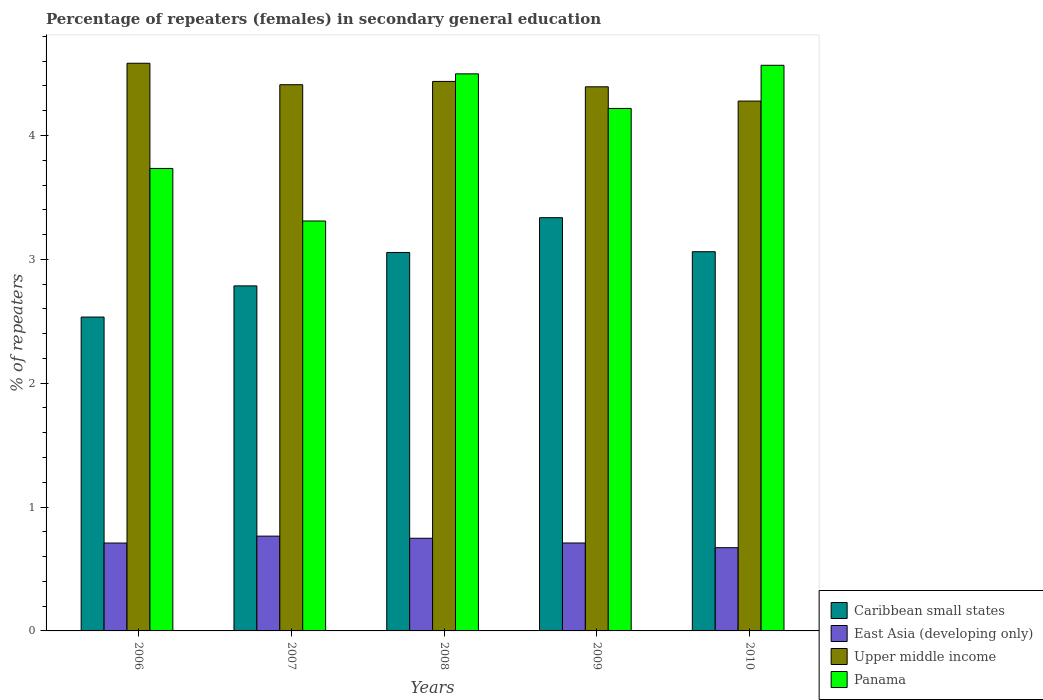How many groups of bars are there?
Your answer should be compact. 5. Are the number of bars per tick equal to the number of legend labels?
Give a very brief answer. Yes. How many bars are there on the 4th tick from the left?
Provide a short and direct response. 4. How many bars are there on the 3rd tick from the right?
Give a very brief answer. 4. What is the label of the 1st group of bars from the left?
Offer a terse response. 2006. In how many cases, is the number of bars for a given year not equal to the number of legend labels?
Offer a very short reply. 0. What is the percentage of female repeaters in Caribbean small states in 2010?
Your answer should be very brief. 3.06. Across all years, what is the maximum percentage of female repeaters in Upper middle income?
Your response must be concise. 4.58. Across all years, what is the minimum percentage of female repeaters in Caribbean small states?
Offer a terse response. 2.53. In which year was the percentage of female repeaters in Caribbean small states maximum?
Ensure brevity in your answer.  2009. In which year was the percentage of female repeaters in Upper middle income minimum?
Offer a terse response. 2010. What is the total percentage of female repeaters in East Asia (developing only) in the graph?
Provide a short and direct response. 3.61. What is the difference between the percentage of female repeaters in East Asia (developing only) in 2006 and that in 2009?
Provide a short and direct response. -0. What is the difference between the percentage of female repeaters in Caribbean small states in 2008 and the percentage of female repeaters in Upper middle income in 2010?
Make the answer very short. -1.22. What is the average percentage of female repeaters in East Asia (developing only) per year?
Provide a succinct answer. 0.72. In the year 2008, what is the difference between the percentage of female repeaters in Panama and percentage of female repeaters in Caribbean small states?
Ensure brevity in your answer.  1.44. In how many years, is the percentage of female repeaters in East Asia (developing only) greater than 4.6 %?
Your answer should be very brief. 0. What is the ratio of the percentage of female repeaters in Panama in 2007 to that in 2008?
Provide a succinct answer. 0.74. What is the difference between the highest and the second highest percentage of female repeaters in Panama?
Give a very brief answer. 0.07. What is the difference between the highest and the lowest percentage of female repeaters in Panama?
Offer a very short reply. 1.26. Is the sum of the percentage of female repeaters in East Asia (developing only) in 2006 and 2009 greater than the maximum percentage of female repeaters in Upper middle income across all years?
Give a very brief answer. No. What does the 1st bar from the left in 2007 represents?
Your answer should be very brief. Caribbean small states. What does the 3rd bar from the right in 2006 represents?
Make the answer very short. East Asia (developing only). How many years are there in the graph?
Your answer should be very brief. 5. Are the values on the major ticks of Y-axis written in scientific E-notation?
Your answer should be compact. No. Does the graph contain any zero values?
Offer a terse response. No. How many legend labels are there?
Ensure brevity in your answer.  4. How are the legend labels stacked?
Keep it short and to the point. Vertical. What is the title of the graph?
Provide a succinct answer. Percentage of repeaters (females) in secondary general education. What is the label or title of the X-axis?
Your response must be concise. Years. What is the label or title of the Y-axis?
Offer a very short reply. % of repeaters. What is the % of repeaters in Caribbean small states in 2006?
Give a very brief answer. 2.53. What is the % of repeaters of East Asia (developing only) in 2006?
Keep it short and to the point. 0.71. What is the % of repeaters of Upper middle income in 2006?
Give a very brief answer. 4.58. What is the % of repeaters of Panama in 2006?
Offer a terse response. 3.73. What is the % of repeaters of Caribbean small states in 2007?
Offer a terse response. 2.79. What is the % of repeaters of East Asia (developing only) in 2007?
Provide a succinct answer. 0.77. What is the % of repeaters in Upper middle income in 2007?
Keep it short and to the point. 4.41. What is the % of repeaters in Panama in 2007?
Your response must be concise. 3.31. What is the % of repeaters of Caribbean small states in 2008?
Offer a terse response. 3.06. What is the % of repeaters in East Asia (developing only) in 2008?
Your answer should be compact. 0.75. What is the % of repeaters of Upper middle income in 2008?
Your answer should be very brief. 4.44. What is the % of repeaters of Panama in 2008?
Provide a short and direct response. 4.5. What is the % of repeaters of Caribbean small states in 2009?
Give a very brief answer. 3.34. What is the % of repeaters of East Asia (developing only) in 2009?
Keep it short and to the point. 0.71. What is the % of repeaters of Upper middle income in 2009?
Make the answer very short. 4.39. What is the % of repeaters of Panama in 2009?
Offer a very short reply. 4.22. What is the % of repeaters of Caribbean small states in 2010?
Ensure brevity in your answer.  3.06. What is the % of repeaters of East Asia (developing only) in 2010?
Your answer should be very brief. 0.67. What is the % of repeaters in Upper middle income in 2010?
Make the answer very short. 4.28. What is the % of repeaters in Panama in 2010?
Offer a terse response. 4.57. Across all years, what is the maximum % of repeaters in Caribbean small states?
Ensure brevity in your answer.  3.34. Across all years, what is the maximum % of repeaters in East Asia (developing only)?
Offer a terse response. 0.77. Across all years, what is the maximum % of repeaters of Upper middle income?
Provide a succinct answer. 4.58. Across all years, what is the maximum % of repeaters in Panama?
Offer a terse response. 4.57. Across all years, what is the minimum % of repeaters in Caribbean small states?
Provide a succinct answer. 2.53. Across all years, what is the minimum % of repeaters of East Asia (developing only)?
Your response must be concise. 0.67. Across all years, what is the minimum % of repeaters in Upper middle income?
Provide a short and direct response. 4.28. Across all years, what is the minimum % of repeaters in Panama?
Your answer should be very brief. 3.31. What is the total % of repeaters of Caribbean small states in the graph?
Offer a very short reply. 14.77. What is the total % of repeaters of East Asia (developing only) in the graph?
Give a very brief answer. 3.6. What is the total % of repeaters of Upper middle income in the graph?
Your answer should be very brief. 22.1. What is the total % of repeaters in Panama in the graph?
Provide a succinct answer. 20.33. What is the difference between the % of repeaters in Caribbean small states in 2006 and that in 2007?
Ensure brevity in your answer.  -0.25. What is the difference between the % of repeaters in East Asia (developing only) in 2006 and that in 2007?
Offer a very short reply. -0.06. What is the difference between the % of repeaters in Upper middle income in 2006 and that in 2007?
Your answer should be compact. 0.17. What is the difference between the % of repeaters of Panama in 2006 and that in 2007?
Give a very brief answer. 0.42. What is the difference between the % of repeaters of Caribbean small states in 2006 and that in 2008?
Your answer should be very brief. -0.52. What is the difference between the % of repeaters of East Asia (developing only) in 2006 and that in 2008?
Keep it short and to the point. -0.04. What is the difference between the % of repeaters in Upper middle income in 2006 and that in 2008?
Ensure brevity in your answer.  0.15. What is the difference between the % of repeaters in Panama in 2006 and that in 2008?
Your response must be concise. -0.76. What is the difference between the % of repeaters of Caribbean small states in 2006 and that in 2009?
Make the answer very short. -0.8. What is the difference between the % of repeaters in East Asia (developing only) in 2006 and that in 2009?
Offer a terse response. -0. What is the difference between the % of repeaters in Upper middle income in 2006 and that in 2009?
Make the answer very short. 0.19. What is the difference between the % of repeaters of Panama in 2006 and that in 2009?
Ensure brevity in your answer.  -0.48. What is the difference between the % of repeaters of Caribbean small states in 2006 and that in 2010?
Your answer should be very brief. -0.53. What is the difference between the % of repeaters of East Asia (developing only) in 2006 and that in 2010?
Make the answer very short. 0.04. What is the difference between the % of repeaters in Upper middle income in 2006 and that in 2010?
Give a very brief answer. 0.31. What is the difference between the % of repeaters in Panama in 2006 and that in 2010?
Keep it short and to the point. -0.83. What is the difference between the % of repeaters in Caribbean small states in 2007 and that in 2008?
Ensure brevity in your answer.  -0.27. What is the difference between the % of repeaters in East Asia (developing only) in 2007 and that in 2008?
Your response must be concise. 0.02. What is the difference between the % of repeaters of Upper middle income in 2007 and that in 2008?
Provide a short and direct response. -0.03. What is the difference between the % of repeaters of Panama in 2007 and that in 2008?
Offer a terse response. -1.19. What is the difference between the % of repeaters in Caribbean small states in 2007 and that in 2009?
Your answer should be compact. -0.55. What is the difference between the % of repeaters of East Asia (developing only) in 2007 and that in 2009?
Your response must be concise. 0.06. What is the difference between the % of repeaters of Upper middle income in 2007 and that in 2009?
Your response must be concise. 0.02. What is the difference between the % of repeaters of Panama in 2007 and that in 2009?
Make the answer very short. -0.91. What is the difference between the % of repeaters of Caribbean small states in 2007 and that in 2010?
Give a very brief answer. -0.28. What is the difference between the % of repeaters of East Asia (developing only) in 2007 and that in 2010?
Offer a terse response. 0.09. What is the difference between the % of repeaters of Upper middle income in 2007 and that in 2010?
Make the answer very short. 0.13. What is the difference between the % of repeaters of Panama in 2007 and that in 2010?
Ensure brevity in your answer.  -1.26. What is the difference between the % of repeaters of Caribbean small states in 2008 and that in 2009?
Offer a terse response. -0.28. What is the difference between the % of repeaters of East Asia (developing only) in 2008 and that in 2009?
Provide a succinct answer. 0.04. What is the difference between the % of repeaters in Upper middle income in 2008 and that in 2009?
Keep it short and to the point. 0.04. What is the difference between the % of repeaters of Panama in 2008 and that in 2009?
Ensure brevity in your answer.  0.28. What is the difference between the % of repeaters of Caribbean small states in 2008 and that in 2010?
Ensure brevity in your answer.  -0.01. What is the difference between the % of repeaters of East Asia (developing only) in 2008 and that in 2010?
Your response must be concise. 0.08. What is the difference between the % of repeaters of Upper middle income in 2008 and that in 2010?
Provide a succinct answer. 0.16. What is the difference between the % of repeaters of Panama in 2008 and that in 2010?
Make the answer very short. -0.07. What is the difference between the % of repeaters in Caribbean small states in 2009 and that in 2010?
Keep it short and to the point. 0.27. What is the difference between the % of repeaters of East Asia (developing only) in 2009 and that in 2010?
Your response must be concise. 0.04. What is the difference between the % of repeaters in Upper middle income in 2009 and that in 2010?
Provide a succinct answer. 0.12. What is the difference between the % of repeaters of Panama in 2009 and that in 2010?
Your answer should be compact. -0.35. What is the difference between the % of repeaters in Caribbean small states in 2006 and the % of repeaters in East Asia (developing only) in 2007?
Make the answer very short. 1.77. What is the difference between the % of repeaters of Caribbean small states in 2006 and the % of repeaters of Upper middle income in 2007?
Make the answer very short. -1.88. What is the difference between the % of repeaters in Caribbean small states in 2006 and the % of repeaters in Panama in 2007?
Your response must be concise. -0.78. What is the difference between the % of repeaters of East Asia (developing only) in 2006 and the % of repeaters of Upper middle income in 2007?
Keep it short and to the point. -3.7. What is the difference between the % of repeaters of East Asia (developing only) in 2006 and the % of repeaters of Panama in 2007?
Give a very brief answer. -2.6. What is the difference between the % of repeaters in Upper middle income in 2006 and the % of repeaters in Panama in 2007?
Keep it short and to the point. 1.27. What is the difference between the % of repeaters of Caribbean small states in 2006 and the % of repeaters of East Asia (developing only) in 2008?
Your response must be concise. 1.79. What is the difference between the % of repeaters of Caribbean small states in 2006 and the % of repeaters of Upper middle income in 2008?
Keep it short and to the point. -1.9. What is the difference between the % of repeaters of Caribbean small states in 2006 and the % of repeaters of Panama in 2008?
Your answer should be compact. -1.96. What is the difference between the % of repeaters of East Asia (developing only) in 2006 and the % of repeaters of Upper middle income in 2008?
Provide a short and direct response. -3.73. What is the difference between the % of repeaters in East Asia (developing only) in 2006 and the % of repeaters in Panama in 2008?
Provide a succinct answer. -3.79. What is the difference between the % of repeaters in Upper middle income in 2006 and the % of repeaters in Panama in 2008?
Make the answer very short. 0.09. What is the difference between the % of repeaters of Caribbean small states in 2006 and the % of repeaters of East Asia (developing only) in 2009?
Keep it short and to the point. 1.82. What is the difference between the % of repeaters of Caribbean small states in 2006 and the % of repeaters of Upper middle income in 2009?
Offer a terse response. -1.86. What is the difference between the % of repeaters of Caribbean small states in 2006 and the % of repeaters of Panama in 2009?
Keep it short and to the point. -1.68. What is the difference between the % of repeaters in East Asia (developing only) in 2006 and the % of repeaters in Upper middle income in 2009?
Give a very brief answer. -3.68. What is the difference between the % of repeaters in East Asia (developing only) in 2006 and the % of repeaters in Panama in 2009?
Provide a short and direct response. -3.51. What is the difference between the % of repeaters in Upper middle income in 2006 and the % of repeaters in Panama in 2009?
Ensure brevity in your answer.  0.36. What is the difference between the % of repeaters in Caribbean small states in 2006 and the % of repeaters in East Asia (developing only) in 2010?
Offer a terse response. 1.86. What is the difference between the % of repeaters of Caribbean small states in 2006 and the % of repeaters of Upper middle income in 2010?
Your answer should be compact. -1.74. What is the difference between the % of repeaters of Caribbean small states in 2006 and the % of repeaters of Panama in 2010?
Ensure brevity in your answer.  -2.03. What is the difference between the % of repeaters of East Asia (developing only) in 2006 and the % of repeaters of Upper middle income in 2010?
Your answer should be compact. -3.57. What is the difference between the % of repeaters in East Asia (developing only) in 2006 and the % of repeaters in Panama in 2010?
Your answer should be very brief. -3.86. What is the difference between the % of repeaters in Upper middle income in 2006 and the % of repeaters in Panama in 2010?
Give a very brief answer. 0.02. What is the difference between the % of repeaters in Caribbean small states in 2007 and the % of repeaters in East Asia (developing only) in 2008?
Ensure brevity in your answer.  2.04. What is the difference between the % of repeaters of Caribbean small states in 2007 and the % of repeaters of Upper middle income in 2008?
Keep it short and to the point. -1.65. What is the difference between the % of repeaters of Caribbean small states in 2007 and the % of repeaters of Panama in 2008?
Provide a short and direct response. -1.71. What is the difference between the % of repeaters of East Asia (developing only) in 2007 and the % of repeaters of Upper middle income in 2008?
Ensure brevity in your answer.  -3.67. What is the difference between the % of repeaters in East Asia (developing only) in 2007 and the % of repeaters in Panama in 2008?
Provide a succinct answer. -3.73. What is the difference between the % of repeaters in Upper middle income in 2007 and the % of repeaters in Panama in 2008?
Provide a short and direct response. -0.09. What is the difference between the % of repeaters of Caribbean small states in 2007 and the % of repeaters of East Asia (developing only) in 2009?
Offer a very short reply. 2.08. What is the difference between the % of repeaters of Caribbean small states in 2007 and the % of repeaters of Upper middle income in 2009?
Your response must be concise. -1.61. What is the difference between the % of repeaters in Caribbean small states in 2007 and the % of repeaters in Panama in 2009?
Your answer should be compact. -1.43. What is the difference between the % of repeaters of East Asia (developing only) in 2007 and the % of repeaters of Upper middle income in 2009?
Ensure brevity in your answer.  -3.63. What is the difference between the % of repeaters of East Asia (developing only) in 2007 and the % of repeaters of Panama in 2009?
Offer a terse response. -3.45. What is the difference between the % of repeaters in Upper middle income in 2007 and the % of repeaters in Panama in 2009?
Ensure brevity in your answer.  0.19. What is the difference between the % of repeaters of Caribbean small states in 2007 and the % of repeaters of East Asia (developing only) in 2010?
Provide a short and direct response. 2.11. What is the difference between the % of repeaters in Caribbean small states in 2007 and the % of repeaters in Upper middle income in 2010?
Keep it short and to the point. -1.49. What is the difference between the % of repeaters in Caribbean small states in 2007 and the % of repeaters in Panama in 2010?
Keep it short and to the point. -1.78. What is the difference between the % of repeaters of East Asia (developing only) in 2007 and the % of repeaters of Upper middle income in 2010?
Give a very brief answer. -3.51. What is the difference between the % of repeaters in East Asia (developing only) in 2007 and the % of repeaters in Panama in 2010?
Provide a short and direct response. -3.8. What is the difference between the % of repeaters of Upper middle income in 2007 and the % of repeaters of Panama in 2010?
Offer a very short reply. -0.16. What is the difference between the % of repeaters of Caribbean small states in 2008 and the % of repeaters of East Asia (developing only) in 2009?
Make the answer very short. 2.35. What is the difference between the % of repeaters in Caribbean small states in 2008 and the % of repeaters in Upper middle income in 2009?
Ensure brevity in your answer.  -1.34. What is the difference between the % of repeaters of Caribbean small states in 2008 and the % of repeaters of Panama in 2009?
Make the answer very short. -1.16. What is the difference between the % of repeaters in East Asia (developing only) in 2008 and the % of repeaters in Upper middle income in 2009?
Offer a terse response. -3.65. What is the difference between the % of repeaters in East Asia (developing only) in 2008 and the % of repeaters in Panama in 2009?
Provide a succinct answer. -3.47. What is the difference between the % of repeaters of Upper middle income in 2008 and the % of repeaters of Panama in 2009?
Offer a terse response. 0.22. What is the difference between the % of repeaters of Caribbean small states in 2008 and the % of repeaters of East Asia (developing only) in 2010?
Your answer should be very brief. 2.38. What is the difference between the % of repeaters of Caribbean small states in 2008 and the % of repeaters of Upper middle income in 2010?
Keep it short and to the point. -1.22. What is the difference between the % of repeaters of Caribbean small states in 2008 and the % of repeaters of Panama in 2010?
Give a very brief answer. -1.51. What is the difference between the % of repeaters of East Asia (developing only) in 2008 and the % of repeaters of Upper middle income in 2010?
Give a very brief answer. -3.53. What is the difference between the % of repeaters in East Asia (developing only) in 2008 and the % of repeaters in Panama in 2010?
Make the answer very short. -3.82. What is the difference between the % of repeaters in Upper middle income in 2008 and the % of repeaters in Panama in 2010?
Provide a short and direct response. -0.13. What is the difference between the % of repeaters of Caribbean small states in 2009 and the % of repeaters of East Asia (developing only) in 2010?
Your answer should be compact. 2.66. What is the difference between the % of repeaters in Caribbean small states in 2009 and the % of repeaters in Upper middle income in 2010?
Give a very brief answer. -0.94. What is the difference between the % of repeaters in Caribbean small states in 2009 and the % of repeaters in Panama in 2010?
Ensure brevity in your answer.  -1.23. What is the difference between the % of repeaters in East Asia (developing only) in 2009 and the % of repeaters in Upper middle income in 2010?
Your answer should be very brief. -3.57. What is the difference between the % of repeaters of East Asia (developing only) in 2009 and the % of repeaters of Panama in 2010?
Offer a terse response. -3.86. What is the difference between the % of repeaters in Upper middle income in 2009 and the % of repeaters in Panama in 2010?
Offer a terse response. -0.17. What is the average % of repeaters in Caribbean small states per year?
Your response must be concise. 2.95. What is the average % of repeaters in East Asia (developing only) per year?
Offer a terse response. 0.72. What is the average % of repeaters of Upper middle income per year?
Ensure brevity in your answer.  4.42. What is the average % of repeaters in Panama per year?
Keep it short and to the point. 4.07. In the year 2006, what is the difference between the % of repeaters of Caribbean small states and % of repeaters of East Asia (developing only)?
Give a very brief answer. 1.82. In the year 2006, what is the difference between the % of repeaters in Caribbean small states and % of repeaters in Upper middle income?
Make the answer very short. -2.05. In the year 2006, what is the difference between the % of repeaters in Caribbean small states and % of repeaters in Panama?
Provide a short and direct response. -1.2. In the year 2006, what is the difference between the % of repeaters of East Asia (developing only) and % of repeaters of Upper middle income?
Make the answer very short. -3.87. In the year 2006, what is the difference between the % of repeaters in East Asia (developing only) and % of repeaters in Panama?
Keep it short and to the point. -3.02. In the year 2006, what is the difference between the % of repeaters of Upper middle income and % of repeaters of Panama?
Give a very brief answer. 0.85. In the year 2007, what is the difference between the % of repeaters of Caribbean small states and % of repeaters of East Asia (developing only)?
Your answer should be very brief. 2.02. In the year 2007, what is the difference between the % of repeaters in Caribbean small states and % of repeaters in Upper middle income?
Make the answer very short. -1.62. In the year 2007, what is the difference between the % of repeaters in Caribbean small states and % of repeaters in Panama?
Your answer should be compact. -0.52. In the year 2007, what is the difference between the % of repeaters in East Asia (developing only) and % of repeaters in Upper middle income?
Offer a terse response. -3.64. In the year 2007, what is the difference between the % of repeaters of East Asia (developing only) and % of repeaters of Panama?
Keep it short and to the point. -2.54. In the year 2007, what is the difference between the % of repeaters in Upper middle income and % of repeaters in Panama?
Keep it short and to the point. 1.1. In the year 2008, what is the difference between the % of repeaters of Caribbean small states and % of repeaters of East Asia (developing only)?
Give a very brief answer. 2.31. In the year 2008, what is the difference between the % of repeaters of Caribbean small states and % of repeaters of Upper middle income?
Your response must be concise. -1.38. In the year 2008, what is the difference between the % of repeaters of Caribbean small states and % of repeaters of Panama?
Your answer should be very brief. -1.44. In the year 2008, what is the difference between the % of repeaters in East Asia (developing only) and % of repeaters in Upper middle income?
Your response must be concise. -3.69. In the year 2008, what is the difference between the % of repeaters of East Asia (developing only) and % of repeaters of Panama?
Your response must be concise. -3.75. In the year 2008, what is the difference between the % of repeaters in Upper middle income and % of repeaters in Panama?
Provide a short and direct response. -0.06. In the year 2009, what is the difference between the % of repeaters of Caribbean small states and % of repeaters of East Asia (developing only)?
Give a very brief answer. 2.63. In the year 2009, what is the difference between the % of repeaters in Caribbean small states and % of repeaters in Upper middle income?
Provide a short and direct response. -1.06. In the year 2009, what is the difference between the % of repeaters of Caribbean small states and % of repeaters of Panama?
Provide a short and direct response. -0.88. In the year 2009, what is the difference between the % of repeaters in East Asia (developing only) and % of repeaters in Upper middle income?
Ensure brevity in your answer.  -3.68. In the year 2009, what is the difference between the % of repeaters of East Asia (developing only) and % of repeaters of Panama?
Your answer should be very brief. -3.51. In the year 2009, what is the difference between the % of repeaters in Upper middle income and % of repeaters in Panama?
Your answer should be compact. 0.17. In the year 2010, what is the difference between the % of repeaters of Caribbean small states and % of repeaters of East Asia (developing only)?
Your answer should be very brief. 2.39. In the year 2010, what is the difference between the % of repeaters in Caribbean small states and % of repeaters in Upper middle income?
Keep it short and to the point. -1.22. In the year 2010, what is the difference between the % of repeaters in Caribbean small states and % of repeaters in Panama?
Make the answer very short. -1.5. In the year 2010, what is the difference between the % of repeaters of East Asia (developing only) and % of repeaters of Upper middle income?
Give a very brief answer. -3.61. In the year 2010, what is the difference between the % of repeaters of East Asia (developing only) and % of repeaters of Panama?
Your answer should be very brief. -3.89. In the year 2010, what is the difference between the % of repeaters in Upper middle income and % of repeaters in Panama?
Your answer should be very brief. -0.29. What is the ratio of the % of repeaters in Caribbean small states in 2006 to that in 2007?
Make the answer very short. 0.91. What is the ratio of the % of repeaters in East Asia (developing only) in 2006 to that in 2007?
Ensure brevity in your answer.  0.93. What is the ratio of the % of repeaters in Upper middle income in 2006 to that in 2007?
Give a very brief answer. 1.04. What is the ratio of the % of repeaters of Panama in 2006 to that in 2007?
Offer a terse response. 1.13. What is the ratio of the % of repeaters of Caribbean small states in 2006 to that in 2008?
Provide a short and direct response. 0.83. What is the ratio of the % of repeaters in East Asia (developing only) in 2006 to that in 2008?
Make the answer very short. 0.95. What is the ratio of the % of repeaters of Upper middle income in 2006 to that in 2008?
Your response must be concise. 1.03. What is the ratio of the % of repeaters of Panama in 2006 to that in 2008?
Offer a terse response. 0.83. What is the ratio of the % of repeaters in Caribbean small states in 2006 to that in 2009?
Provide a succinct answer. 0.76. What is the ratio of the % of repeaters in Upper middle income in 2006 to that in 2009?
Offer a very short reply. 1.04. What is the ratio of the % of repeaters of Panama in 2006 to that in 2009?
Provide a short and direct response. 0.89. What is the ratio of the % of repeaters of Caribbean small states in 2006 to that in 2010?
Provide a short and direct response. 0.83. What is the ratio of the % of repeaters in East Asia (developing only) in 2006 to that in 2010?
Your response must be concise. 1.06. What is the ratio of the % of repeaters of Upper middle income in 2006 to that in 2010?
Provide a succinct answer. 1.07. What is the ratio of the % of repeaters of Panama in 2006 to that in 2010?
Keep it short and to the point. 0.82. What is the ratio of the % of repeaters of Caribbean small states in 2007 to that in 2008?
Keep it short and to the point. 0.91. What is the ratio of the % of repeaters of East Asia (developing only) in 2007 to that in 2008?
Your answer should be very brief. 1.02. What is the ratio of the % of repeaters of Upper middle income in 2007 to that in 2008?
Your answer should be very brief. 0.99. What is the ratio of the % of repeaters in Panama in 2007 to that in 2008?
Offer a very short reply. 0.74. What is the ratio of the % of repeaters of Caribbean small states in 2007 to that in 2009?
Give a very brief answer. 0.83. What is the ratio of the % of repeaters in East Asia (developing only) in 2007 to that in 2009?
Ensure brevity in your answer.  1.08. What is the ratio of the % of repeaters of Upper middle income in 2007 to that in 2009?
Your answer should be very brief. 1. What is the ratio of the % of repeaters of Panama in 2007 to that in 2009?
Your answer should be compact. 0.78. What is the ratio of the % of repeaters of Caribbean small states in 2007 to that in 2010?
Ensure brevity in your answer.  0.91. What is the ratio of the % of repeaters in East Asia (developing only) in 2007 to that in 2010?
Ensure brevity in your answer.  1.14. What is the ratio of the % of repeaters in Upper middle income in 2007 to that in 2010?
Keep it short and to the point. 1.03. What is the ratio of the % of repeaters of Panama in 2007 to that in 2010?
Provide a succinct answer. 0.72. What is the ratio of the % of repeaters of Caribbean small states in 2008 to that in 2009?
Give a very brief answer. 0.92. What is the ratio of the % of repeaters in East Asia (developing only) in 2008 to that in 2009?
Offer a terse response. 1.05. What is the ratio of the % of repeaters of Upper middle income in 2008 to that in 2009?
Your answer should be very brief. 1.01. What is the ratio of the % of repeaters of Panama in 2008 to that in 2009?
Keep it short and to the point. 1.07. What is the ratio of the % of repeaters in East Asia (developing only) in 2008 to that in 2010?
Your answer should be compact. 1.11. What is the ratio of the % of repeaters of Upper middle income in 2008 to that in 2010?
Your answer should be very brief. 1.04. What is the ratio of the % of repeaters of Panama in 2008 to that in 2010?
Offer a terse response. 0.98. What is the ratio of the % of repeaters in Caribbean small states in 2009 to that in 2010?
Offer a very short reply. 1.09. What is the ratio of the % of repeaters in East Asia (developing only) in 2009 to that in 2010?
Offer a very short reply. 1.06. What is the ratio of the % of repeaters in Upper middle income in 2009 to that in 2010?
Your answer should be very brief. 1.03. What is the ratio of the % of repeaters of Panama in 2009 to that in 2010?
Your answer should be compact. 0.92. What is the difference between the highest and the second highest % of repeaters in Caribbean small states?
Your answer should be compact. 0.27. What is the difference between the highest and the second highest % of repeaters of East Asia (developing only)?
Provide a short and direct response. 0.02. What is the difference between the highest and the second highest % of repeaters in Upper middle income?
Offer a terse response. 0.15. What is the difference between the highest and the second highest % of repeaters of Panama?
Offer a very short reply. 0.07. What is the difference between the highest and the lowest % of repeaters in Caribbean small states?
Give a very brief answer. 0.8. What is the difference between the highest and the lowest % of repeaters of East Asia (developing only)?
Keep it short and to the point. 0.09. What is the difference between the highest and the lowest % of repeaters in Upper middle income?
Keep it short and to the point. 0.31. What is the difference between the highest and the lowest % of repeaters in Panama?
Keep it short and to the point. 1.26. 